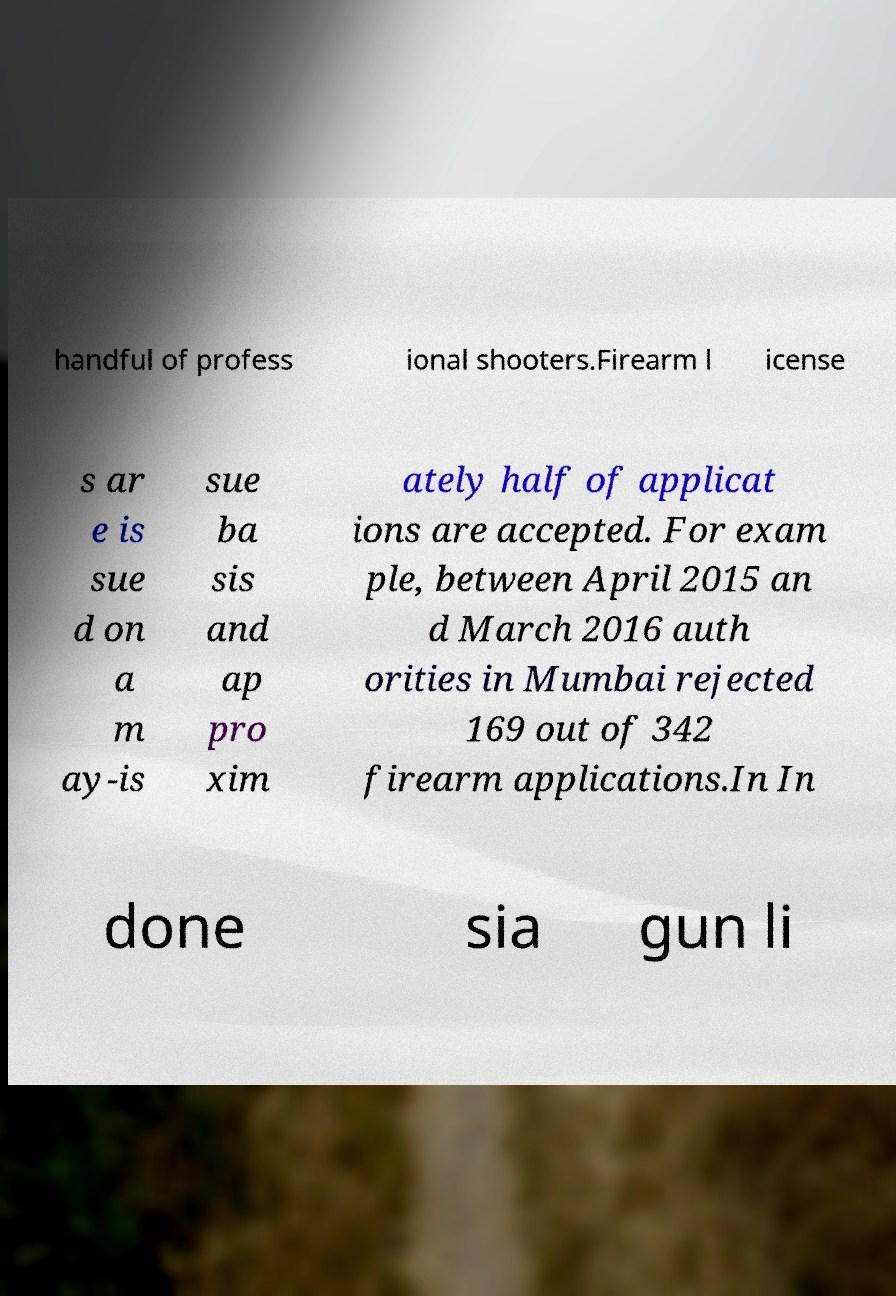Could you assist in decoding the text presented in this image and type it out clearly? handful of profess ional shooters.Firearm l icense s ar e is sue d on a m ay-is sue ba sis and ap pro xim ately half of applicat ions are accepted. For exam ple, between April 2015 an d March 2016 auth orities in Mumbai rejected 169 out of 342 firearm applications.In In done sia gun li 